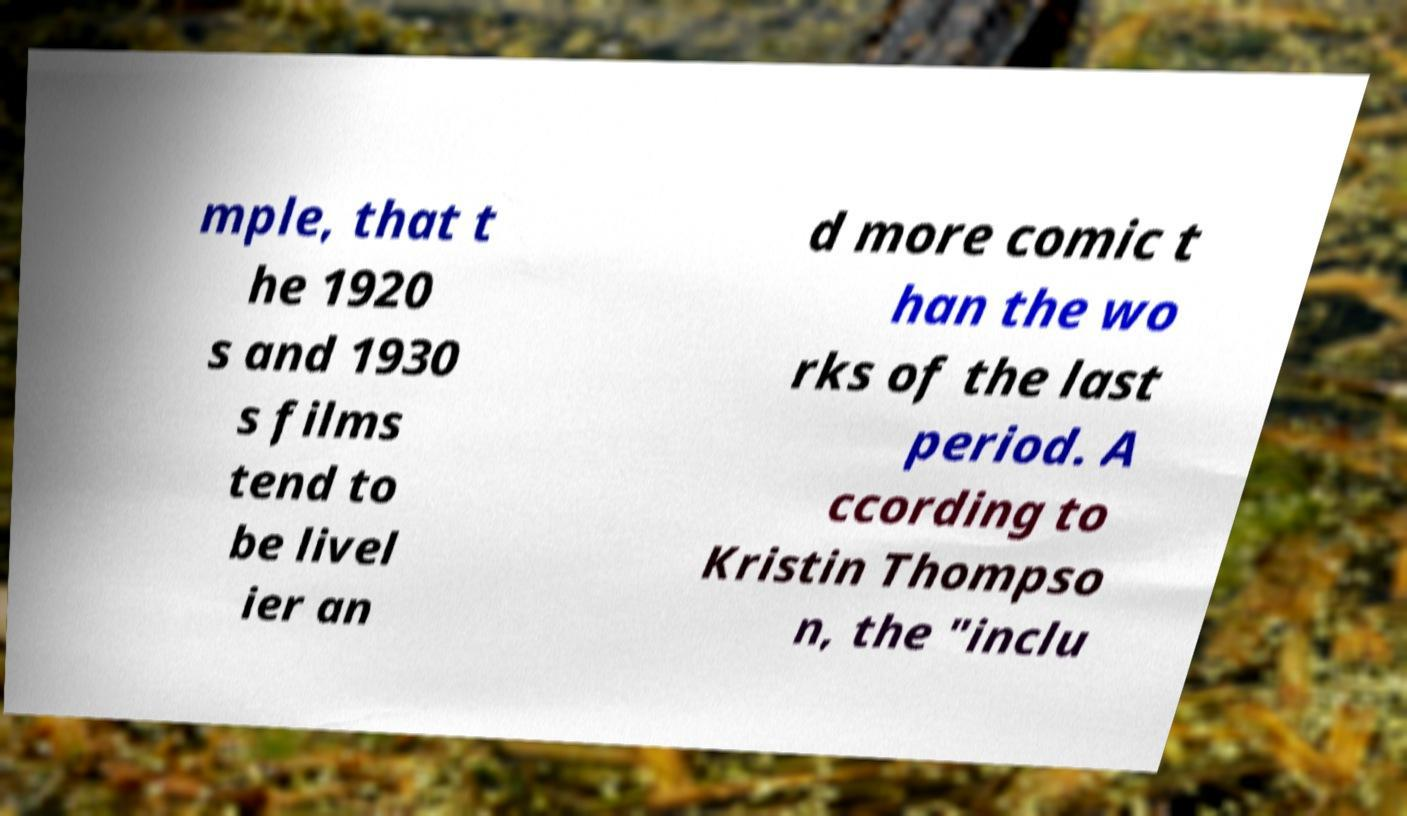Can you read and provide the text displayed in the image?This photo seems to have some interesting text. Can you extract and type it out for me? mple, that t he 1920 s and 1930 s films tend to be livel ier an d more comic t han the wo rks of the last period. A ccording to Kristin Thompso n, the "inclu 